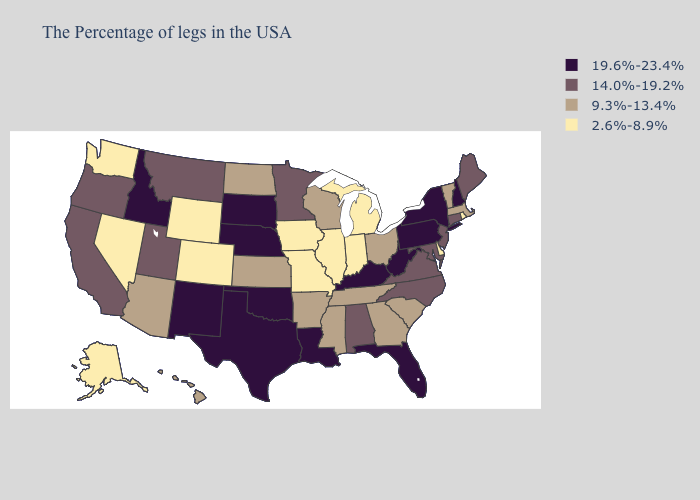Among the states that border Minnesota , which have the highest value?
Short answer required. South Dakota. Does Alaska have the highest value in the West?
Be succinct. No. Does Oklahoma have the highest value in the USA?
Give a very brief answer. Yes. Which states have the highest value in the USA?
Write a very short answer. New Hampshire, New York, Pennsylvania, West Virginia, Florida, Kentucky, Louisiana, Nebraska, Oklahoma, Texas, South Dakota, New Mexico, Idaho. What is the highest value in the MidWest ?
Be succinct. 19.6%-23.4%. What is the value of Mississippi?
Be succinct. 9.3%-13.4%. What is the highest value in the USA?
Quick response, please. 19.6%-23.4%. Name the states that have a value in the range 2.6%-8.9%?
Write a very short answer. Rhode Island, Delaware, Michigan, Indiana, Illinois, Missouri, Iowa, Wyoming, Colorado, Nevada, Washington, Alaska. Name the states that have a value in the range 9.3%-13.4%?
Give a very brief answer. Massachusetts, Vermont, South Carolina, Ohio, Georgia, Tennessee, Wisconsin, Mississippi, Arkansas, Kansas, North Dakota, Arizona, Hawaii. Which states have the lowest value in the West?
Short answer required. Wyoming, Colorado, Nevada, Washington, Alaska. What is the value of Oregon?
Be succinct. 14.0%-19.2%. Does Delaware have the same value as Illinois?
Give a very brief answer. Yes. What is the value of New York?
Quick response, please. 19.6%-23.4%. What is the highest value in states that border South Carolina?
Give a very brief answer. 14.0%-19.2%. Name the states that have a value in the range 14.0%-19.2%?
Short answer required. Maine, Connecticut, New Jersey, Maryland, Virginia, North Carolina, Alabama, Minnesota, Utah, Montana, California, Oregon. 